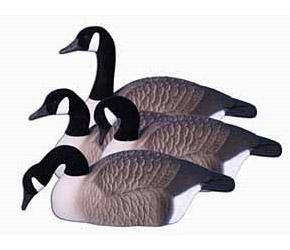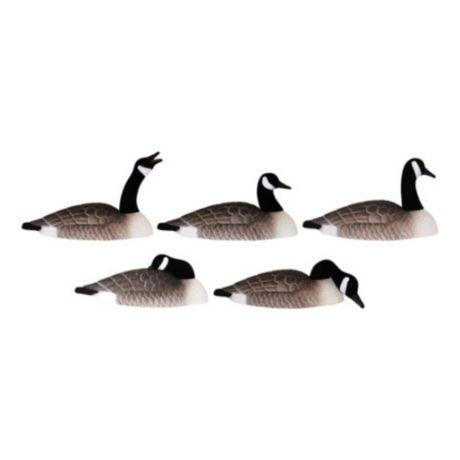The first image is the image on the left, the second image is the image on the right. Considering the images on both sides, is "All geese have flat bases without legs, black necks, and folded wings." valid? Answer yes or no. Yes. The first image is the image on the left, the second image is the image on the right. Examine the images to the left and right. Is the description "The geese in one image have dark orange beaks." accurate? Answer yes or no. No. 